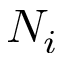<formula> <loc_0><loc_0><loc_500><loc_500>N _ { i }</formula> 